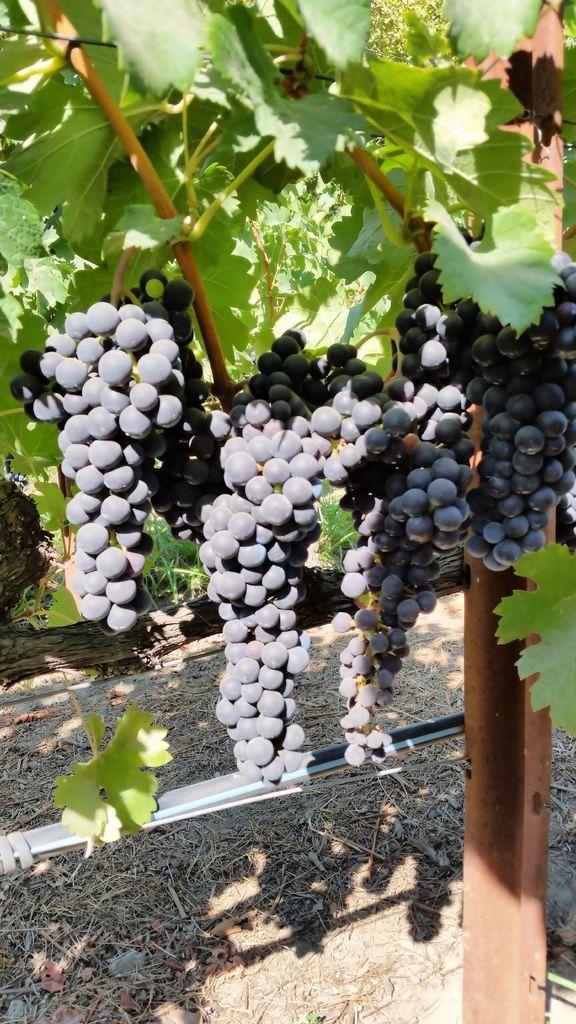Could you give a brief overview of what you see in this image? In this image I can see few fruits in black color. In the background I can see few leaves in green color. 